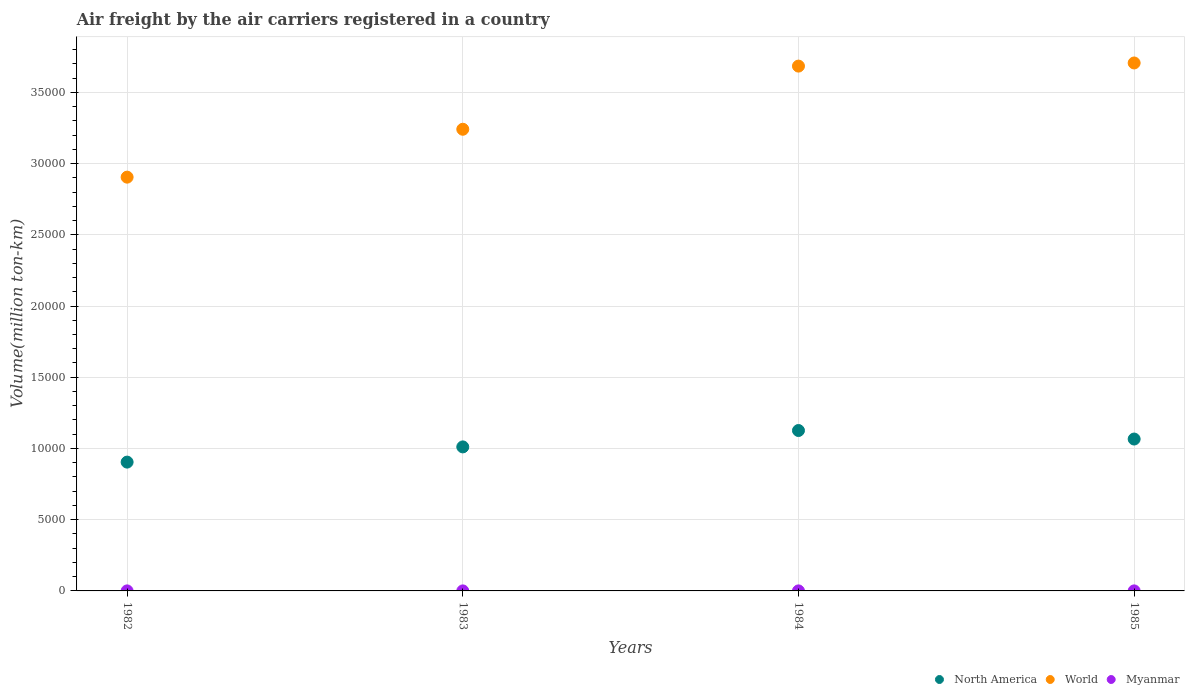What is the volume of the air carriers in Myanmar in 1982?
Ensure brevity in your answer.  1.7. Across all years, what is the maximum volume of the air carriers in World?
Ensure brevity in your answer.  3.71e+04. Across all years, what is the minimum volume of the air carriers in World?
Make the answer very short. 2.90e+04. In which year was the volume of the air carriers in North America maximum?
Your answer should be very brief. 1984. What is the total volume of the air carriers in World in the graph?
Provide a short and direct response. 1.35e+05. What is the difference between the volume of the air carriers in North America in 1983 and that in 1984?
Give a very brief answer. -1150.2. What is the difference between the volume of the air carriers in Myanmar in 1985 and the volume of the air carriers in North America in 1982?
Provide a short and direct response. -9040.1. What is the average volume of the air carriers in Myanmar per year?
Give a very brief answer. 1.97. In the year 1983, what is the difference between the volume of the air carriers in North America and volume of the air carriers in Myanmar?
Your answer should be compact. 1.01e+04. What is the ratio of the volume of the air carriers in North America in 1984 to that in 1985?
Offer a very short reply. 1.06. What is the difference between the highest and the second highest volume of the air carriers in World?
Keep it short and to the point. 219.7. What is the difference between the highest and the lowest volume of the air carriers in North America?
Your answer should be compact. 2217.9. Is the volume of the air carriers in North America strictly greater than the volume of the air carriers in World over the years?
Make the answer very short. No. Is the volume of the air carriers in Myanmar strictly less than the volume of the air carriers in World over the years?
Your answer should be compact. Yes. How many dotlines are there?
Your answer should be compact. 3. How many years are there in the graph?
Your response must be concise. 4. Are the values on the major ticks of Y-axis written in scientific E-notation?
Give a very brief answer. No. Does the graph contain any zero values?
Your answer should be very brief. No. Does the graph contain grids?
Provide a succinct answer. Yes. Where does the legend appear in the graph?
Provide a short and direct response. Bottom right. What is the title of the graph?
Provide a succinct answer. Air freight by the air carriers registered in a country. Does "Burkina Faso" appear as one of the legend labels in the graph?
Your answer should be very brief. No. What is the label or title of the Y-axis?
Ensure brevity in your answer.  Volume(million ton-km). What is the Volume(million ton-km) of North America in 1982?
Your answer should be very brief. 9042.4. What is the Volume(million ton-km) of World in 1982?
Your answer should be very brief. 2.90e+04. What is the Volume(million ton-km) of Myanmar in 1982?
Provide a succinct answer. 1.7. What is the Volume(million ton-km) of North America in 1983?
Your answer should be very brief. 1.01e+04. What is the Volume(million ton-km) of World in 1983?
Your answer should be very brief. 3.24e+04. What is the Volume(million ton-km) of Myanmar in 1983?
Offer a terse response. 1.6. What is the Volume(million ton-km) of North America in 1984?
Provide a short and direct response. 1.13e+04. What is the Volume(million ton-km) of World in 1984?
Provide a short and direct response. 3.68e+04. What is the Volume(million ton-km) in Myanmar in 1984?
Give a very brief answer. 2.3. What is the Volume(million ton-km) of North America in 1985?
Keep it short and to the point. 1.07e+04. What is the Volume(million ton-km) of World in 1985?
Keep it short and to the point. 3.71e+04. What is the Volume(million ton-km) of Myanmar in 1985?
Your response must be concise. 2.3. Across all years, what is the maximum Volume(million ton-km) of North America?
Offer a very short reply. 1.13e+04. Across all years, what is the maximum Volume(million ton-km) of World?
Your response must be concise. 3.71e+04. Across all years, what is the maximum Volume(million ton-km) in Myanmar?
Ensure brevity in your answer.  2.3. Across all years, what is the minimum Volume(million ton-km) in North America?
Make the answer very short. 9042.4. Across all years, what is the minimum Volume(million ton-km) in World?
Offer a very short reply. 2.90e+04. Across all years, what is the minimum Volume(million ton-km) of Myanmar?
Your answer should be compact. 1.6. What is the total Volume(million ton-km) of North America in the graph?
Make the answer very short. 4.11e+04. What is the total Volume(million ton-km) of World in the graph?
Provide a succinct answer. 1.35e+05. What is the difference between the Volume(million ton-km) in North America in 1982 and that in 1983?
Your response must be concise. -1067.7. What is the difference between the Volume(million ton-km) of World in 1982 and that in 1983?
Ensure brevity in your answer.  -3361.6. What is the difference between the Volume(million ton-km) in Myanmar in 1982 and that in 1983?
Ensure brevity in your answer.  0.1. What is the difference between the Volume(million ton-km) of North America in 1982 and that in 1984?
Provide a succinct answer. -2217.9. What is the difference between the Volume(million ton-km) in World in 1982 and that in 1984?
Provide a succinct answer. -7795.7. What is the difference between the Volume(million ton-km) of Myanmar in 1982 and that in 1984?
Make the answer very short. -0.6. What is the difference between the Volume(million ton-km) in North America in 1982 and that in 1985?
Provide a short and direct response. -1619.6. What is the difference between the Volume(million ton-km) in World in 1982 and that in 1985?
Keep it short and to the point. -8015.4. What is the difference between the Volume(million ton-km) of Myanmar in 1982 and that in 1985?
Make the answer very short. -0.6. What is the difference between the Volume(million ton-km) in North America in 1983 and that in 1984?
Your response must be concise. -1150.2. What is the difference between the Volume(million ton-km) in World in 1983 and that in 1984?
Offer a very short reply. -4434.1. What is the difference between the Volume(million ton-km) of North America in 1983 and that in 1985?
Your answer should be compact. -551.9. What is the difference between the Volume(million ton-km) of World in 1983 and that in 1985?
Your answer should be compact. -4653.8. What is the difference between the Volume(million ton-km) of North America in 1984 and that in 1985?
Your answer should be compact. 598.3. What is the difference between the Volume(million ton-km) of World in 1984 and that in 1985?
Your answer should be compact. -219.7. What is the difference between the Volume(million ton-km) of Myanmar in 1984 and that in 1985?
Your answer should be very brief. 0. What is the difference between the Volume(million ton-km) in North America in 1982 and the Volume(million ton-km) in World in 1983?
Your answer should be very brief. -2.34e+04. What is the difference between the Volume(million ton-km) of North America in 1982 and the Volume(million ton-km) of Myanmar in 1983?
Offer a very short reply. 9040.8. What is the difference between the Volume(million ton-km) of World in 1982 and the Volume(million ton-km) of Myanmar in 1983?
Offer a terse response. 2.90e+04. What is the difference between the Volume(million ton-km) of North America in 1982 and the Volume(million ton-km) of World in 1984?
Make the answer very short. -2.78e+04. What is the difference between the Volume(million ton-km) of North America in 1982 and the Volume(million ton-km) of Myanmar in 1984?
Provide a short and direct response. 9040.1. What is the difference between the Volume(million ton-km) in World in 1982 and the Volume(million ton-km) in Myanmar in 1984?
Provide a short and direct response. 2.90e+04. What is the difference between the Volume(million ton-km) in North America in 1982 and the Volume(million ton-km) in World in 1985?
Your response must be concise. -2.80e+04. What is the difference between the Volume(million ton-km) of North America in 1982 and the Volume(million ton-km) of Myanmar in 1985?
Your answer should be very brief. 9040.1. What is the difference between the Volume(million ton-km) of World in 1982 and the Volume(million ton-km) of Myanmar in 1985?
Provide a succinct answer. 2.90e+04. What is the difference between the Volume(million ton-km) in North America in 1983 and the Volume(million ton-km) in World in 1984?
Offer a terse response. -2.67e+04. What is the difference between the Volume(million ton-km) in North America in 1983 and the Volume(million ton-km) in Myanmar in 1984?
Your answer should be very brief. 1.01e+04. What is the difference between the Volume(million ton-km) of World in 1983 and the Volume(million ton-km) of Myanmar in 1984?
Your response must be concise. 3.24e+04. What is the difference between the Volume(million ton-km) of North America in 1983 and the Volume(million ton-km) of World in 1985?
Give a very brief answer. -2.70e+04. What is the difference between the Volume(million ton-km) in North America in 1983 and the Volume(million ton-km) in Myanmar in 1985?
Offer a very short reply. 1.01e+04. What is the difference between the Volume(million ton-km) in World in 1983 and the Volume(million ton-km) in Myanmar in 1985?
Your response must be concise. 3.24e+04. What is the difference between the Volume(million ton-km) of North America in 1984 and the Volume(million ton-km) of World in 1985?
Keep it short and to the point. -2.58e+04. What is the difference between the Volume(million ton-km) of North America in 1984 and the Volume(million ton-km) of Myanmar in 1985?
Offer a very short reply. 1.13e+04. What is the difference between the Volume(million ton-km) of World in 1984 and the Volume(million ton-km) of Myanmar in 1985?
Your response must be concise. 3.68e+04. What is the average Volume(million ton-km) of North America per year?
Your answer should be compact. 1.03e+04. What is the average Volume(million ton-km) of World per year?
Make the answer very short. 3.38e+04. What is the average Volume(million ton-km) in Myanmar per year?
Offer a very short reply. 1.98. In the year 1982, what is the difference between the Volume(million ton-km) in North America and Volume(million ton-km) in World?
Give a very brief answer. -2.00e+04. In the year 1982, what is the difference between the Volume(million ton-km) of North America and Volume(million ton-km) of Myanmar?
Offer a terse response. 9040.7. In the year 1982, what is the difference between the Volume(million ton-km) of World and Volume(million ton-km) of Myanmar?
Ensure brevity in your answer.  2.90e+04. In the year 1983, what is the difference between the Volume(million ton-km) in North America and Volume(million ton-km) in World?
Keep it short and to the point. -2.23e+04. In the year 1983, what is the difference between the Volume(million ton-km) of North America and Volume(million ton-km) of Myanmar?
Make the answer very short. 1.01e+04. In the year 1983, what is the difference between the Volume(million ton-km) of World and Volume(million ton-km) of Myanmar?
Make the answer very short. 3.24e+04. In the year 1984, what is the difference between the Volume(million ton-km) of North America and Volume(million ton-km) of World?
Give a very brief answer. -2.56e+04. In the year 1984, what is the difference between the Volume(million ton-km) of North America and Volume(million ton-km) of Myanmar?
Your answer should be compact. 1.13e+04. In the year 1984, what is the difference between the Volume(million ton-km) in World and Volume(million ton-km) in Myanmar?
Your response must be concise. 3.68e+04. In the year 1985, what is the difference between the Volume(million ton-km) of North America and Volume(million ton-km) of World?
Your answer should be very brief. -2.64e+04. In the year 1985, what is the difference between the Volume(million ton-km) in North America and Volume(million ton-km) in Myanmar?
Ensure brevity in your answer.  1.07e+04. In the year 1985, what is the difference between the Volume(million ton-km) of World and Volume(million ton-km) of Myanmar?
Give a very brief answer. 3.71e+04. What is the ratio of the Volume(million ton-km) in North America in 1982 to that in 1983?
Offer a terse response. 0.89. What is the ratio of the Volume(million ton-km) in World in 1982 to that in 1983?
Give a very brief answer. 0.9. What is the ratio of the Volume(million ton-km) of Myanmar in 1982 to that in 1983?
Provide a succinct answer. 1.06. What is the ratio of the Volume(million ton-km) in North America in 1982 to that in 1984?
Your answer should be very brief. 0.8. What is the ratio of the Volume(million ton-km) of World in 1982 to that in 1984?
Your response must be concise. 0.79. What is the ratio of the Volume(million ton-km) in Myanmar in 1982 to that in 1984?
Offer a very short reply. 0.74. What is the ratio of the Volume(million ton-km) in North America in 1982 to that in 1985?
Your answer should be very brief. 0.85. What is the ratio of the Volume(million ton-km) in World in 1982 to that in 1985?
Provide a short and direct response. 0.78. What is the ratio of the Volume(million ton-km) of Myanmar in 1982 to that in 1985?
Your response must be concise. 0.74. What is the ratio of the Volume(million ton-km) in North America in 1983 to that in 1984?
Keep it short and to the point. 0.9. What is the ratio of the Volume(million ton-km) in World in 1983 to that in 1984?
Make the answer very short. 0.88. What is the ratio of the Volume(million ton-km) in Myanmar in 1983 to that in 1984?
Provide a succinct answer. 0.7. What is the ratio of the Volume(million ton-km) of North America in 1983 to that in 1985?
Your answer should be very brief. 0.95. What is the ratio of the Volume(million ton-km) of World in 1983 to that in 1985?
Offer a very short reply. 0.87. What is the ratio of the Volume(million ton-km) in Myanmar in 1983 to that in 1985?
Make the answer very short. 0.7. What is the ratio of the Volume(million ton-km) of North America in 1984 to that in 1985?
Your answer should be compact. 1.06. What is the difference between the highest and the second highest Volume(million ton-km) in North America?
Your response must be concise. 598.3. What is the difference between the highest and the second highest Volume(million ton-km) in World?
Offer a very short reply. 219.7. What is the difference between the highest and the second highest Volume(million ton-km) of Myanmar?
Keep it short and to the point. 0. What is the difference between the highest and the lowest Volume(million ton-km) of North America?
Give a very brief answer. 2217.9. What is the difference between the highest and the lowest Volume(million ton-km) in World?
Provide a succinct answer. 8015.4. What is the difference between the highest and the lowest Volume(million ton-km) in Myanmar?
Give a very brief answer. 0.7. 